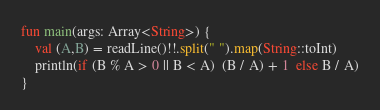<code> <loc_0><loc_0><loc_500><loc_500><_Kotlin_>fun main(args: Array<String>) {
    val (A,B) = readLine()!!.split(" ").map(String::toInt)
    println(if (B % A > 0 || B < A)  (B / A) + 1  else B / A)
}</code> 